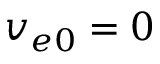<formula> <loc_0><loc_0><loc_500><loc_500>v _ { e 0 } = 0</formula> 